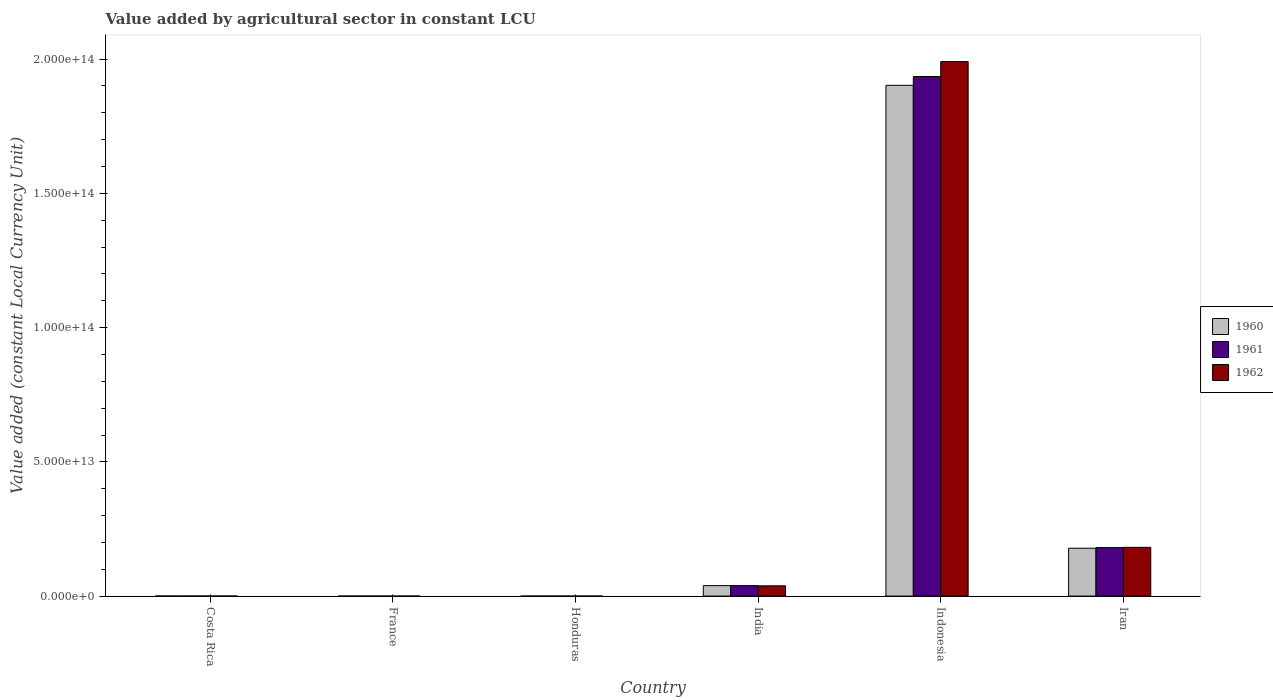How many different coloured bars are there?
Keep it short and to the point. 3. How many groups of bars are there?
Give a very brief answer. 6. Are the number of bars per tick equal to the number of legend labels?
Keep it short and to the point. Yes. How many bars are there on the 4th tick from the left?
Offer a terse response. 3. How many bars are there on the 6th tick from the right?
Keep it short and to the point. 3. What is the label of the 6th group of bars from the left?
Your answer should be very brief. Iran. In how many cases, is the number of bars for a given country not equal to the number of legend labels?
Your response must be concise. 0. What is the value added by agricultural sector in 1961 in Costa Rica?
Ensure brevity in your answer.  3.36e+1. Across all countries, what is the maximum value added by agricultural sector in 1961?
Make the answer very short. 1.94e+14. Across all countries, what is the minimum value added by agricultural sector in 1960?
Make the answer very short. 4.44e+09. In which country was the value added by agricultural sector in 1962 maximum?
Offer a very short reply. Indonesia. In which country was the value added by agricultural sector in 1962 minimum?
Make the answer very short. Honduras. What is the total value added by agricultural sector in 1962 in the graph?
Your answer should be compact. 2.21e+14. What is the difference between the value added by agricultural sector in 1960 in France and that in Honduras?
Make the answer very short. 8.72e+09. What is the difference between the value added by agricultural sector in 1960 in France and the value added by agricultural sector in 1961 in Iran?
Offer a terse response. -1.81e+13. What is the average value added by agricultural sector in 1962 per country?
Give a very brief answer. 3.69e+13. What is the difference between the value added by agricultural sector of/in 1960 and value added by agricultural sector of/in 1962 in Indonesia?
Give a very brief answer. -8.83e+12. What is the ratio of the value added by agricultural sector in 1962 in Costa Rica to that in France?
Make the answer very short. 2.63. What is the difference between the highest and the second highest value added by agricultural sector in 1962?
Give a very brief answer. -1.81e+14. What is the difference between the highest and the lowest value added by agricultural sector in 1960?
Your answer should be very brief. 1.90e+14. In how many countries, is the value added by agricultural sector in 1962 greater than the average value added by agricultural sector in 1962 taken over all countries?
Provide a short and direct response. 1. Is the sum of the value added by agricultural sector in 1961 in Costa Rica and Honduras greater than the maximum value added by agricultural sector in 1962 across all countries?
Offer a terse response. No. What does the 1st bar from the left in France represents?
Your answer should be compact. 1960. How many countries are there in the graph?
Provide a short and direct response. 6. What is the difference between two consecutive major ticks on the Y-axis?
Provide a succinct answer. 5.00e+13. Are the values on the major ticks of Y-axis written in scientific E-notation?
Ensure brevity in your answer.  Yes. Where does the legend appear in the graph?
Give a very brief answer. Center right. What is the title of the graph?
Provide a succinct answer. Value added by agricultural sector in constant LCU. What is the label or title of the X-axis?
Offer a very short reply. Country. What is the label or title of the Y-axis?
Your response must be concise. Value added (constant Local Currency Unit). What is the Value added (constant Local Currency Unit) in 1960 in Costa Rica?
Make the answer very short. 3.24e+1. What is the Value added (constant Local Currency Unit) of 1961 in Costa Rica?
Provide a short and direct response. 3.36e+1. What is the Value added (constant Local Currency Unit) of 1962 in Costa Rica?
Offer a terse response. 3.57e+1. What is the Value added (constant Local Currency Unit) of 1960 in France?
Ensure brevity in your answer.  1.32e+1. What is the Value added (constant Local Currency Unit) in 1961 in France?
Make the answer very short. 1.25e+1. What is the Value added (constant Local Currency Unit) in 1962 in France?
Provide a succinct answer. 1.36e+1. What is the Value added (constant Local Currency Unit) of 1960 in Honduras?
Provide a short and direct response. 4.44e+09. What is the Value added (constant Local Currency Unit) in 1961 in Honduras?
Ensure brevity in your answer.  4.73e+09. What is the Value added (constant Local Currency Unit) of 1962 in Honduras?
Offer a very short reply. 4.96e+09. What is the Value added (constant Local Currency Unit) of 1960 in India?
Give a very brief answer. 3.90e+12. What is the Value added (constant Local Currency Unit) in 1961 in India?
Your answer should be very brief. 3.91e+12. What is the Value added (constant Local Currency Unit) in 1962 in India?
Ensure brevity in your answer.  3.83e+12. What is the Value added (constant Local Currency Unit) in 1960 in Indonesia?
Offer a terse response. 1.90e+14. What is the Value added (constant Local Currency Unit) in 1961 in Indonesia?
Your answer should be very brief. 1.94e+14. What is the Value added (constant Local Currency Unit) of 1962 in Indonesia?
Offer a terse response. 1.99e+14. What is the Value added (constant Local Currency Unit) of 1960 in Iran?
Ensure brevity in your answer.  1.78e+13. What is the Value added (constant Local Currency Unit) in 1961 in Iran?
Your answer should be very brief. 1.81e+13. What is the Value added (constant Local Currency Unit) of 1962 in Iran?
Provide a short and direct response. 1.82e+13. Across all countries, what is the maximum Value added (constant Local Currency Unit) in 1960?
Provide a succinct answer. 1.90e+14. Across all countries, what is the maximum Value added (constant Local Currency Unit) in 1961?
Your answer should be compact. 1.94e+14. Across all countries, what is the maximum Value added (constant Local Currency Unit) in 1962?
Keep it short and to the point. 1.99e+14. Across all countries, what is the minimum Value added (constant Local Currency Unit) of 1960?
Provide a succinct answer. 4.44e+09. Across all countries, what is the minimum Value added (constant Local Currency Unit) in 1961?
Your answer should be very brief. 4.73e+09. Across all countries, what is the minimum Value added (constant Local Currency Unit) in 1962?
Offer a terse response. 4.96e+09. What is the total Value added (constant Local Currency Unit) of 1960 in the graph?
Offer a terse response. 2.12e+14. What is the total Value added (constant Local Currency Unit) of 1961 in the graph?
Give a very brief answer. 2.16e+14. What is the total Value added (constant Local Currency Unit) in 1962 in the graph?
Offer a terse response. 2.21e+14. What is the difference between the Value added (constant Local Currency Unit) in 1960 in Costa Rica and that in France?
Your response must be concise. 1.92e+1. What is the difference between the Value added (constant Local Currency Unit) in 1961 in Costa Rica and that in France?
Provide a succinct answer. 2.11e+1. What is the difference between the Value added (constant Local Currency Unit) of 1962 in Costa Rica and that in France?
Provide a short and direct response. 2.21e+1. What is the difference between the Value added (constant Local Currency Unit) of 1960 in Costa Rica and that in Honduras?
Offer a terse response. 2.80e+1. What is the difference between the Value added (constant Local Currency Unit) in 1961 in Costa Rica and that in Honduras?
Your answer should be very brief. 2.89e+1. What is the difference between the Value added (constant Local Currency Unit) in 1962 in Costa Rica and that in Honduras?
Keep it short and to the point. 3.07e+1. What is the difference between the Value added (constant Local Currency Unit) in 1960 in Costa Rica and that in India?
Provide a succinct answer. -3.87e+12. What is the difference between the Value added (constant Local Currency Unit) of 1961 in Costa Rica and that in India?
Your response must be concise. -3.87e+12. What is the difference between the Value added (constant Local Currency Unit) in 1962 in Costa Rica and that in India?
Your answer should be very brief. -3.79e+12. What is the difference between the Value added (constant Local Currency Unit) of 1960 in Costa Rica and that in Indonesia?
Offer a very short reply. -1.90e+14. What is the difference between the Value added (constant Local Currency Unit) of 1961 in Costa Rica and that in Indonesia?
Offer a terse response. -1.93e+14. What is the difference between the Value added (constant Local Currency Unit) of 1962 in Costa Rica and that in Indonesia?
Offer a very short reply. -1.99e+14. What is the difference between the Value added (constant Local Currency Unit) of 1960 in Costa Rica and that in Iran?
Offer a very short reply. -1.78e+13. What is the difference between the Value added (constant Local Currency Unit) of 1961 in Costa Rica and that in Iran?
Your answer should be very brief. -1.80e+13. What is the difference between the Value added (constant Local Currency Unit) in 1962 in Costa Rica and that in Iran?
Make the answer very short. -1.81e+13. What is the difference between the Value added (constant Local Currency Unit) in 1960 in France and that in Honduras?
Give a very brief answer. 8.72e+09. What is the difference between the Value added (constant Local Currency Unit) of 1961 in France and that in Honduras?
Ensure brevity in your answer.  7.74e+09. What is the difference between the Value added (constant Local Currency Unit) of 1962 in France and that in Honduras?
Keep it short and to the point. 8.63e+09. What is the difference between the Value added (constant Local Currency Unit) of 1960 in France and that in India?
Ensure brevity in your answer.  -3.89e+12. What is the difference between the Value added (constant Local Currency Unit) in 1961 in France and that in India?
Your response must be concise. -3.90e+12. What is the difference between the Value added (constant Local Currency Unit) of 1962 in France and that in India?
Keep it short and to the point. -3.82e+12. What is the difference between the Value added (constant Local Currency Unit) in 1960 in France and that in Indonesia?
Give a very brief answer. -1.90e+14. What is the difference between the Value added (constant Local Currency Unit) in 1961 in France and that in Indonesia?
Offer a terse response. -1.94e+14. What is the difference between the Value added (constant Local Currency Unit) of 1962 in France and that in Indonesia?
Provide a succinct answer. -1.99e+14. What is the difference between the Value added (constant Local Currency Unit) of 1960 in France and that in Iran?
Provide a short and direct response. -1.78e+13. What is the difference between the Value added (constant Local Currency Unit) of 1961 in France and that in Iran?
Make the answer very short. -1.81e+13. What is the difference between the Value added (constant Local Currency Unit) in 1962 in France and that in Iran?
Provide a short and direct response. -1.81e+13. What is the difference between the Value added (constant Local Currency Unit) of 1960 in Honduras and that in India?
Offer a very short reply. -3.90e+12. What is the difference between the Value added (constant Local Currency Unit) in 1961 in Honduras and that in India?
Make the answer very short. -3.90e+12. What is the difference between the Value added (constant Local Currency Unit) in 1962 in Honduras and that in India?
Offer a very short reply. -3.82e+12. What is the difference between the Value added (constant Local Currency Unit) in 1960 in Honduras and that in Indonesia?
Your answer should be compact. -1.90e+14. What is the difference between the Value added (constant Local Currency Unit) in 1961 in Honduras and that in Indonesia?
Ensure brevity in your answer.  -1.94e+14. What is the difference between the Value added (constant Local Currency Unit) of 1962 in Honduras and that in Indonesia?
Keep it short and to the point. -1.99e+14. What is the difference between the Value added (constant Local Currency Unit) in 1960 in Honduras and that in Iran?
Ensure brevity in your answer.  -1.78e+13. What is the difference between the Value added (constant Local Currency Unit) of 1961 in Honduras and that in Iran?
Make the answer very short. -1.81e+13. What is the difference between the Value added (constant Local Currency Unit) of 1962 in Honduras and that in Iran?
Offer a very short reply. -1.82e+13. What is the difference between the Value added (constant Local Currency Unit) in 1960 in India and that in Indonesia?
Ensure brevity in your answer.  -1.86e+14. What is the difference between the Value added (constant Local Currency Unit) in 1961 in India and that in Indonesia?
Offer a very short reply. -1.90e+14. What is the difference between the Value added (constant Local Currency Unit) in 1962 in India and that in Indonesia?
Provide a short and direct response. -1.95e+14. What is the difference between the Value added (constant Local Currency Unit) in 1960 in India and that in Iran?
Provide a short and direct response. -1.39e+13. What is the difference between the Value added (constant Local Currency Unit) of 1961 in India and that in Iran?
Make the answer very short. -1.42e+13. What is the difference between the Value added (constant Local Currency Unit) in 1962 in India and that in Iran?
Your answer should be very brief. -1.43e+13. What is the difference between the Value added (constant Local Currency Unit) in 1960 in Indonesia and that in Iran?
Make the answer very short. 1.72e+14. What is the difference between the Value added (constant Local Currency Unit) of 1961 in Indonesia and that in Iran?
Your answer should be compact. 1.75e+14. What is the difference between the Value added (constant Local Currency Unit) in 1962 in Indonesia and that in Iran?
Give a very brief answer. 1.81e+14. What is the difference between the Value added (constant Local Currency Unit) in 1960 in Costa Rica and the Value added (constant Local Currency Unit) in 1961 in France?
Your response must be concise. 1.99e+1. What is the difference between the Value added (constant Local Currency Unit) of 1960 in Costa Rica and the Value added (constant Local Currency Unit) of 1962 in France?
Ensure brevity in your answer.  1.88e+1. What is the difference between the Value added (constant Local Currency Unit) of 1961 in Costa Rica and the Value added (constant Local Currency Unit) of 1962 in France?
Ensure brevity in your answer.  2.00e+1. What is the difference between the Value added (constant Local Currency Unit) in 1960 in Costa Rica and the Value added (constant Local Currency Unit) in 1961 in Honduras?
Give a very brief answer. 2.77e+1. What is the difference between the Value added (constant Local Currency Unit) in 1960 in Costa Rica and the Value added (constant Local Currency Unit) in 1962 in Honduras?
Provide a short and direct response. 2.74e+1. What is the difference between the Value added (constant Local Currency Unit) of 1961 in Costa Rica and the Value added (constant Local Currency Unit) of 1962 in Honduras?
Offer a terse response. 2.86e+1. What is the difference between the Value added (constant Local Currency Unit) of 1960 in Costa Rica and the Value added (constant Local Currency Unit) of 1961 in India?
Offer a terse response. -3.88e+12. What is the difference between the Value added (constant Local Currency Unit) of 1960 in Costa Rica and the Value added (constant Local Currency Unit) of 1962 in India?
Give a very brief answer. -3.80e+12. What is the difference between the Value added (constant Local Currency Unit) in 1961 in Costa Rica and the Value added (constant Local Currency Unit) in 1962 in India?
Provide a short and direct response. -3.80e+12. What is the difference between the Value added (constant Local Currency Unit) of 1960 in Costa Rica and the Value added (constant Local Currency Unit) of 1961 in Indonesia?
Make the answer very short. -1.93e+14. What is the difference between the Value added (constant Local Currency Unit) in 1960 in Costa Rica and the Value added (constant Local Currency Unit) in 1962 in Indonesia?
Keep it short and to the point. -1.99e+14. What is the difference between the Value added (constant Local Currency Unit) in 1961 in Costa Rica and the Value added (constant Local Currency Unit) in 1962 in Indonesia?
Your response must be concise. -1.99e+14. What is the difference between the Value added (constant Local Currency Unit) of 1960 in Costa Rica and the Value added (constant Local Currency Unit) of 1961 in Iran?
Your answer should be very brief. -1.80e+13. What is the difference between the Value added (constant Local Currency Unit) in 1960 in Costa Rica and the Value added (constant Local Currency Unit) in 1962 in Iran?
Ensure brevity in your answer.  -1.81e+13. What is the difference between the Value added (constant Local Currency Unit) in 1961 in Costa Rica and the Value added (constant Local Currency Unit) in 1962 in Iran?
Give a very brief answer. -1.81e+13. What is the difference between the Value added (constant Local Currency Unit) in 1960 in France and the Value added (constant Local Currency Unit) in 1961 in Honduras?
Ensure brevity in your answer.  8.43e+09. What is the difference between the Value added (constant Local Currency Unit) in 1960 in France and the Value added (constant Local Currency Unit) in 1962 in Honduras?
Make the answer very short. 8.20e+09. What is the difference between the Value added (constant Local Currency Unit) in 1961 in France and the Value added (constant Local Currency Unit) in 1962 in Honduras?
Offer a terse response. 7.52e+09. What is the difference between the Value added (constant Local Currency Unit) in 1960 in France and the Value added (constant Local Currency Unit) in 1961 in India?
Offer a very short reply. -3.89e+12. What is the difference between the Value added (constant Local Currency Unit) in 1960 in France and the Value added (constant Local Currency Unit) in 1962 in India?
Ensure brevity in your answer.  -3.82e+12. What is the difference between the Value added (constant Local Currency Unit) of 1961 in France and the Value added (constant Local Currency Unit) of 1962 in India?
Provide a succinct answer. -3.82e+12. What is the difference between the Value added (constant Local Currency Unit) of 1960 in France and the Value added (constant Local Currency Unit) of 1961 in Indonesia?
Offer a terse response. -1.94e+14. What is the difference between the Value added (constant Local Currency Unit) in 1960 in France and the Value added (constant Local Currency Unit) in 1962 in Indonesia?
Your answer should be compact. -1.99e+14. What is the difference between the Value added (constant Local Currency Unit) in 1961 in France and the Value added (constant Local Currency Unit) in 1962 in Indonesia?
Ensure brevity in your answer.  -1.99e+14. What is the difference between the Value added (constant Local Currency Unit) of 1960 in France and the Value added (constant Local Currency Unit) of 1961 in Iran?
Ensure brevity in your answer.  -1.81e+13. What is the difference between the Value added (constant Local Currency Unit) in 1960 in France and the Value added (constant Local Currency Unit) in 1962 in Iran?
Ensure brevity in your answer.  -1.81e+13. What is the difference between the Value added (constant Local Currency Unit) of 1961 in France and the Value added (constant Local Currency Unit) of 1962 in Iran?
Ensure brevity in your answer.  -1.81e+13. What is the difference between the Value added (constant Local Currency Unit) in 1960 in Honduras and the Value added (constant Local Currency Unit) in 1961 in India?
Ensure brevity in your answer.  -3.90e+12. What is the difference between the Value added (constant Local Currency Unit) of 1960 in Honduras and the Value added (constant Local Currency Unit) of 1962 in India?
Your answer should be compact. -3.83e+12. What is the difference between the Value added (constant Local Currency Unit) in 1961 in Honduras and the Value added (constant Local Currency Unit) in 1962 in India?
Your answer should be compact. -3.83e+12. What is the difference between the Value added (constant Local Currency Unit) of 1960 in Honduras and the Value added (constant Local Currency Unit) of 1961 in Indonesia?
Your response must be concise. -1.94e+14. What is the difference between the Value added (constant Local Currency Unit) of 1960 in Honduras and the Value added (constant Local Currency Unit) of 1962 in Indonesia?
Make the answer very short. -1.99e+14. What is the difference between the Value added (constant Local Currency Unit) of 1961 in Honduras and the Value added (constant Local Currency Unit) of 1962 in Indonesia?
Make the answer very short. -1.99e+14. What is the difference between the Value added (constant Local Currency Unit) of 1960 in Honduras and the Value added (constant Local Currency Unit) of 1961 in Iran?
Your answer should be compact. -1.81e+13. What is the difference between the Value added (constant Local Currency Unit) of 1960 in Honduras and the Value added (constant Local Currency Unit) of 1962 in Iran?
Keep it short and to the point. -1.82e+13. What is the difference between the Value added (constant Local Currency Unit) in 1961 in Honduras and the Value added (constant Local Currency Unit) in 1962 in Iran?
Your response must be concise. -1.82e+13. What is the difference between the Value added (constant Local Currency Unit) in 1960 in India and the Value added (constant Local Currency Unit) in 1961 in Indonesia?
Your response must be concise. -1.90e+14. What is the difference between the Value added (constant Local Currency Unit) of 1960 in India and the Value added (constant Local Currency Unit) of 1962 in Indonesia?
Offer a very short reply. -1.95e+14. What is the difference between the Value added (constant Local Currency Unit) of 1961 in India and the Value added (constant Local Currency Unit) of 1962 in Indonesia?
Offer a very short reply. -1.95e+14. What is the difference between the Value added (constant Local Currency Unit) in 1960 in India and the Value added (constant Local Currency Unit) in 1961 in Iran?
Offer a very short reply. -1.42e+13. What is the difference between the Value added (constant Local Currency Unit) of 1960 in India and the Value added (constant Local Currency Unit) of 1962 in Iran?
Your response must be concise. -1.43e+13. What is the difference between the Value added (constant Local Currency Unit) in 1961 in India and the Value added (constant Local Currency Unit) in 1962 in Iran?
Your response must be concise. -1.43e+13. What is the difference between the Value added (constant Local Currency Unit) of 1960 in Indonesia and the Value added (constant Local Currency Unit) of 1961 in Iran?
Keep it short and to the point. 1.72e+14. What is the difference between the Value added (constant Local Currency Unit) of 1960 in Indonesia and the Value added (constant Local Currency Unit) of 1962 in Iran?
Ensure brevity in your answer.  1.72e+14. What is the difference between the Value added (constant Local Currency Unit) in 1961 in Indonesia and the Value added (constant Local Currency Unit) in 1962 in Iran?
Keep it short and to the point. 1.75e+14. What is the average Value added (constant Local Currency Unit) in 1960 per country?
Your answer should be compact. 3.53e+13. What is the average Value added (constant Local Currency Unit) in 1961 per country?
Offer a very short reply. 3.59e+13. What is the average Value added (constant Local Currency Unit) of 1962 per country?
Your response must be concise. 3.69e+13. What is the difference between the Value added (constant Local Currency Unit) of 1960 and Value added (constant Local Currency Unit) of 1961 in Costa Rica?
Offer a terse response. -1.19e+09. What is the difference between the Value added (constant Local Currency Unit) of 1960 and Value added (constant Local Currency Unit) of 1962 in Costa Rica?
Provide a short and direct response. -3.25e+09. What is the difference between the Value added (constant Local Currency Unit) of 1961 and Value added (constant Local Currency Unit) of 1962 in Costa Rica?
Keep it short and to the point. -2.06e+09. What is the difference between the Value added (constant Local Currency Unit) in 1960 and Value added (constant Local Currency Unit) in 1961 in France?
Your answer should be very brief. 6.84e+08. What is the difference between the Value added (constant Local Currency Unit) of 1960 and Value added (constant Local Currency Unit) of 1962 in France?
Your response must be concise. -4.23e+08. What is the difference between the Value added (constant Local Currency Unit) in 1961 and Value added (constant Local Currency Unit) in 1962 in France?
Offer a very short reply. -1.11e+09. What is the difference between the Value added (constant Local Currency Unit) of 1960 and Value added (constant Local Currency Unit) of 1961 in Honduras?
Provide a succinct answer. -2.90e+08. What is the difference between the Value added (constant Local Currency Unit) of 1960 and Value added (constant Local Currency Unit) of 1962 in Honduras?
Your answer should be very brief. -5.15e+08. What is the difference between the Value added (constant Local Currency Unit) in 1961 and Value added (constant Local Currency Unit) in 1962 in Honduras?
Keep it short and to the point. -2.25e+08. What is the difference between the Value added (constant Local Currency Unit) of 1960 and Value added (constant Local Currency Unit) of 1961 in India?
Provide a short and direct response. -3.29e+09. What is the difference between the Value added (constant Local Currency Unit) of 1960 and Value added (constant Local Currency Unit) of 1962 in India?
Your answer should be very brief. 7.44e+1. What is the difference between the Value added (constant Local Currency Unit) in 1961 and Value added (constant Local Currency Unit) in 1962 in India?
Provide a short and direct response. 7.77e+1. What is the difference between the Value added (constant Local Currency Unit) in 1960 and Value added (constant Local Currency Unit) in 1961 in Indonesia?
Give a very brief answer. -3.27e+12. What is the difference between the Value added (constant Local Currency Unit) in 1960 and Value added (constant Local Currency Unit) in 1962 in Indonesia?
Make the answer very short. -8.83e+12. What is the difference between the Value added (constant Local Currency Unit) in 1961 and Value added (constant Local Currency Unit) in 1962 in Indonesia?
Ensure brevity in your answer.  -5.56e+12. What is the difference between the Value added (constant Local Currency Unit) in 1960 and Value added (constant Local Currency Unit) in 1961 in Iran?
Make the answer very short. -2.42e+11. What is the difference between the Value added (constant Local Currency Unit) in 1960 and Value added (constant Local Currency Unit) in 1962 in Iran?
Give a very brief answer. -3.32e+11. What is the difference between the Value added (constant Local Currency Unit) of 1961 and Value added (constant Local Currency Unit) of 1962 in Iran?
Make the answer very short. -8.95e+1. What is the ratio of the Value added (constant Local Currency Unit) of 1960 in Costa Rica to that in France?
Your answer should be compact. 2.46. What is the ratio of the Value added (constant Local Currency Unit) of 1961 in Costa Rica to that in France?
Make the answer very short. 2.69. What is the ratio of the Value added (constant Local Currency Unit) in 1962 in Costa Rica to that in France?
Your answer should be very brief. 2.63. What is the ratio of the Value added (constant Local Currency Unit) of 1960 in Costa Rica to that in Honduras?
Your response must be concise. 7.3. What is the ratio of the Value added (constant Local Currency Unit) of 1961 in Costa Rica to that in Honduras?
Your response must be concise. 7.1. What is the ratio of the Value added (constant Local Currency Unit) in 1962 in Costa Rica to that in Honduras?
Provide a short and direct response. 7.2. What is the ratio of the Value added (constant Local Currency Unit) in 1960 in Costa Rica to that in India?
Your response must be concise. 0.01. What is the ratio of the Value added (constant Local Currency Unit) of 1961 in Costa Rica to that in India?
Your response must be concise. 0.01. What is the ratio of the Value added (constant Local Currency Unit) in 1962 in Costa Rica to that in India?
Your response must be concise. 0.01. What is the ratio of the Value added (constant Local Currency Unit) in 1961 in Costa Rica to that in Indonesia?
Make the answer very short. 0. What is the ratio of the Value added (constant Local Currency Unit) in 1962 in Costa Rica to that in Indonesia?
Offer a very short reply. 0. What is the ratio of the Value added (constant Local Currency Unit) in 1960 in Costa Rica to that in Iran?
Your answer should be compact. 0. What is the ratio of the Value added (constant Local Currency Unit) in 1961 in Costa Rica to that in Iran?
Ensure brevity in your answer.  0. What is the ratio of the Value added (constant Local Currency Unit) of 1962 in Costa Rica to that in Iran?
Your answer should be compact. 0. What is the ratio of the Value added (constant Local Currency Unit) in 1960 in France to that in Honduras?
Offer a very short reply. 2.96. What is the ratio of the Value added (constant Local Currency Unit) of 1961 in France to that in Honduras?
Give a very brief answer. 2.64. What is the ratio of the Value added (constant Local Currency Unit) in 1962 in France to that in Honduras?
Keep it short and to the point. 2.74. What is the ratio of the Value added (constant Local Currency Unit) of 1960 in France to that in India?
Your answer should be very brief. 0. What is the ratio of the Value added (constant Local Currency Unit) in 1961 in France to that in India?
Your answer should be very brief. 0. What is the ratio of the Value added (constant Local Currency Unit) in 1962 in France to that in India?
Your answer should be very brief. 0. What is the ratio of the Value added (constant Local Currency Unit) in 1961 in France to that in Indonesia?
Your response must be concise. 0. What is the ratio of the Value added (constant Local Currency Unit) of 1962 in France to that in Indonesia?
Offer a very short reply. 0. What is the ratio of the Value added (constant Local Currency Unit) of 1960 in France to that in Iran?
Keep it short and to the point. 0. What is the ratio of the Value added (constant Local Currency Unit) in 1961 in France to that in Iran?
Your answer should be very brief. 0. What is the ratio of the Value added (constant Local Currency Unit) in 1962 in France to that in Iran?
Offer a very short reply. 0. What is the ratio of the Value added (constant Local Currency Unit) of 1960 in Honduras to that in India?
Offer a very short reply. 0. What is the ratio of the Value added (constant Local Currency Unit) of 1961 in Honduras to that in India?
Ensure brevity in your answer.  0. What is the ratio of the Value added (constant Local Currency Unit) in 1962 in Honduras to that in India?
Your response must be concise. 0. What is the ratio of the Value added (constant Local Currency Unit) in 1960 in Honduras to that in Indonesia?
Provide a succinct answer. 0. What is the ratio of the Value added (constant Local Currency Unit) of 1961 in Honduras to that in Indonesia?
Provide a short and direct response. 0. What is the ratio of the Value added (constant Local Currency Unit) in 1960 in Honduras to that in Iran?
Ensure brevity in your answer.  0. What is the ratio of the Value added (constant Local Currency Unit) in 1961 in Honduras to that in Iran?
Offer a terse response. 0. What is the ratio of the Value added (constant Local Currency Unit) in 1962 in Honduras to that in Iran?
Your answer should be very brief. 0. What is the ratio of the Value added (constant Local Currency Unit) in 1960 in India to that in Indonesia?
Keep it short and to the point. 0.02. What is the ratio of the Value added (constant Local Currency Unit) in 1961 in India to that in Indonesia?
Make the answer very short. 0.02. What is the ratio of the Value added (constant Local Currency Unit) of 1962 in India to that in Indonesia?
Your answer should be compact. 0.02. What is the ratio of the Value added (constant Local Currency Unit) in 1960 in India to that in Iran?
Ensure brevity in your answer.  0.22. What is the ratio of the Value added (constant Local Currency Unit) of 1961 in India to that in Iran?
Your response must be concise. 0.22. What is the ratio of the Value added (constant Local Currency Unit) of 1962 in India to that in Iran?
Give a very brief answer. 0.21. What is the ratio of the Value added (constant Local Currency Unit) of 1960 in Indonesia to that in Iran?
Keep it short and to the point. 10.67. What is the ratio of the Value added (constant Local Currency Unit) of 1961 in Indonesia to that in Iran?
Your answer should be very brief. 10.71. What is the ratio of the Value added (constant Local Currency Unit) of 1962 in Indonesia to that in Iran?
Make the answer very short. 10.96. What is the difference between the highest and the second highest Value added (constant Local Currency Unit) of 1960?
Your answer should be very brief. 1.72e+14. What is the difference between the highest and the second highest Value added (constant Local Currency Unit) of 1961?
Offer a terse response. 1.75e+14. What is the difference between the highest and the second highest Value added (constant Local Currency Unit) of 1962?
Offer a terse response. 1.81e+14. What is the difference between the highest and the lowest Value added (constant Local Currency Unit) of 1960?
Provide a succinct answer. 1.90e+14. What is the difference between the highest and the lowest Value added (constant Local Currency Unit) of 1961?
Your answer should be compact. 1.94e+14. What is the difference between the highest and the lowest Value added (constant Local Currency Unit) of 1962?
Provide a succinct answer. 1.99e+14. 